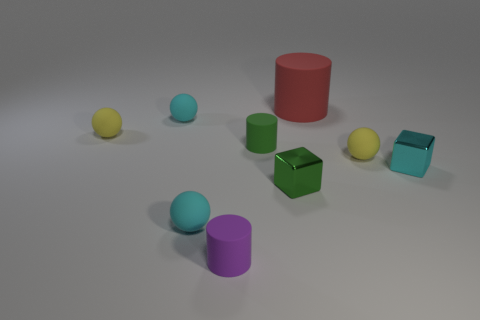Is there any other thing that has the same shape as the large object?
Provide a short and direct response. Yes. How many things are red things or cyan matte things?
Your answer should be very brief. 3. There is a red rubber thing that is the same shape as the small purple object; what size is it?
Make the answer very short. Large. Are there any other things that have the same size as the red matte cylinder?
Your answer should be compact. No. What number of other objects are the same color as the big matte cylinder?
Ensure brevity in your answer.  0. What number of cylinders are big things or small cyan rubber objects?
Your answer should be compact. 1. There is a cylinder behind the yellow rubber object that is to the left of the tiny purple cylinder; what is its color?
Keep it short and to the point. Red. There is a green metal thing; what shape is it?
Your answer should be compact. Cube. Do the cyan metallic object that is behind the green metallic object and the tiny purple thing have the same size?
Offer a terse response. Yes. Are there any purple cylinders made of the same material as the green cylinder?
Offer a terse response. Yes. 